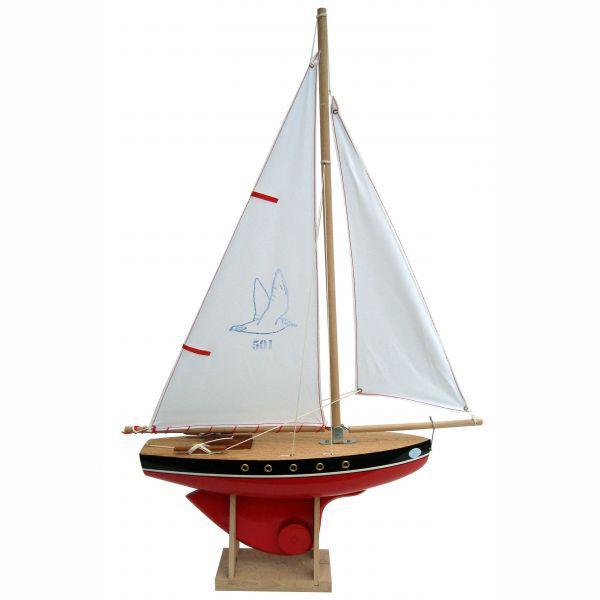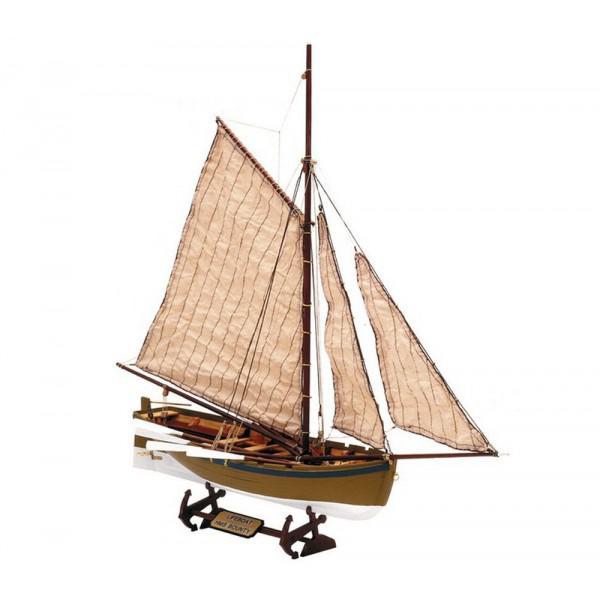The first image is the image on the left, the second image is the image on the right. For the images displayed, is the sentence "Both boats have unfurled sails." factually correct? Answer yes or no. Yes. The first image is the image on the left, the second image is the image on the right. Examine the images to the left and right. Is the description "The left and right images feature the same type of boat model, but the boat on the left has no upright dowel mast, and the boat on the right has an upright mast." accurate? Answer yes or no. No. 